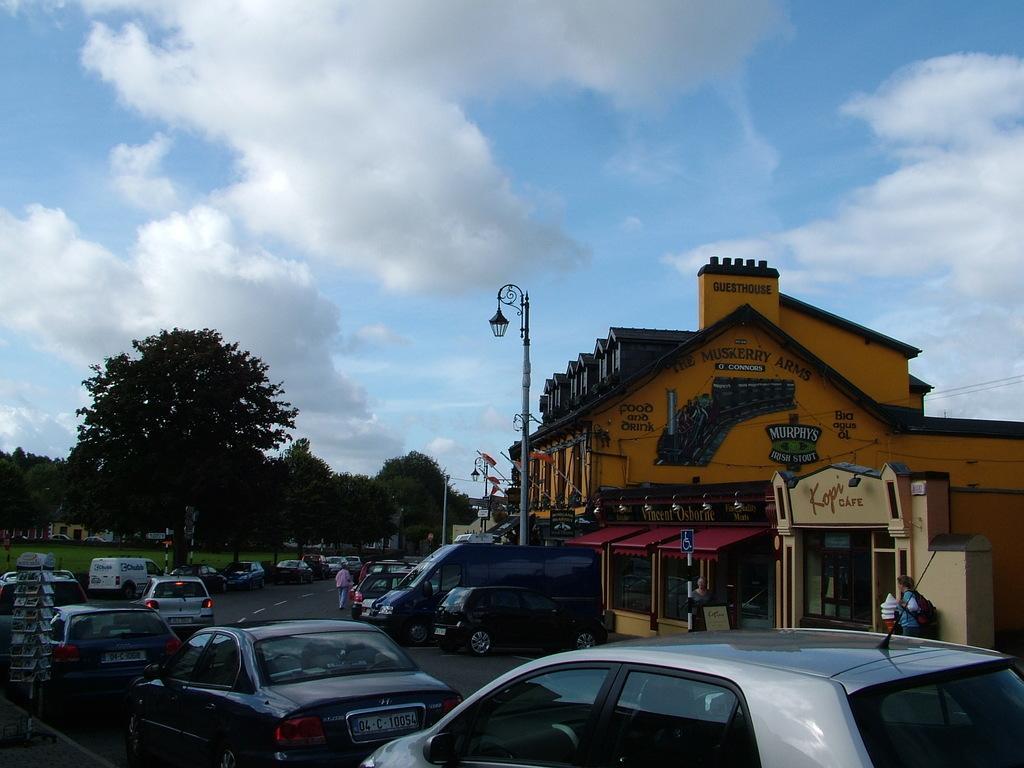Can you describe this image briefly? In this image there are vehicles on the road. There are people. There are light poles, boards and some other objects. In the background of the image there are buildings, trees and there's grass on the surface. At the top of the image there are clouds in the sky. 